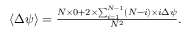Convert formula to latex. <formula><loc_0><loc_0><loc_500><loc_500>\begin{array} { r } { \langle \Delta \psi \rangle = \frac { N \times 0 + 2 \times \sum _ { i = 1 } ^ { N - 1 } ( N - i ) \times i \Delta \psi } { N ^ { 2 } } . } \end{array}</formula> 